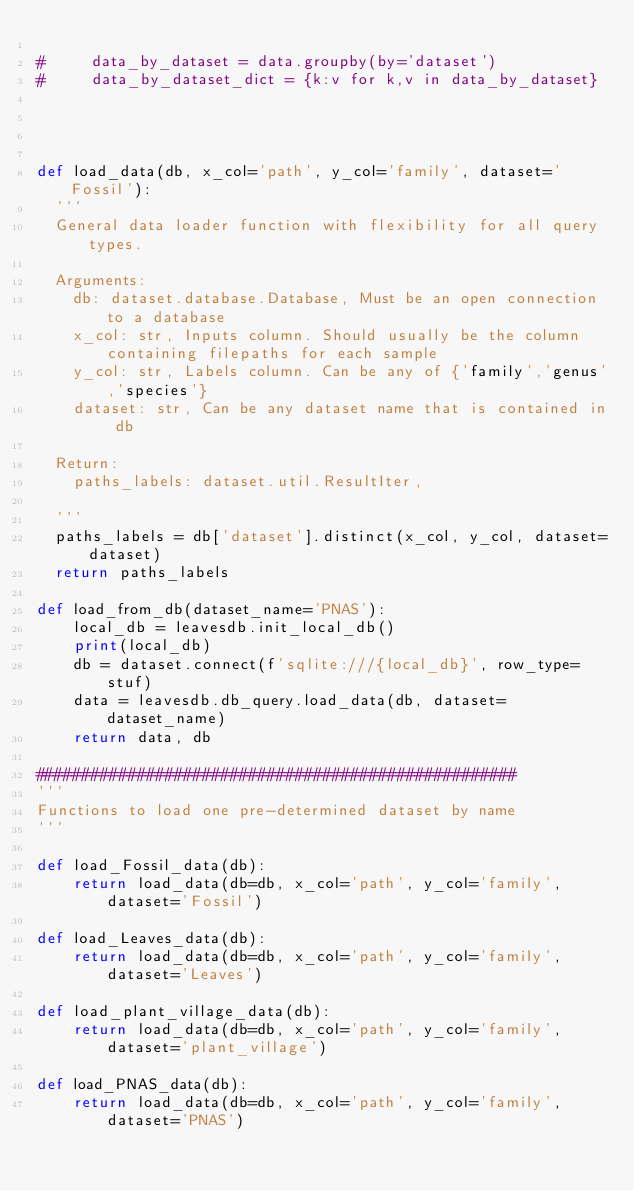<code> <loc_0><loc_0><loc_500><loc_500><_Python_>
#     data_by_dataset = data.groupby(by='dataset')
#     data_by_dataset_dict = {k:v for k,v in data_by_dataset}
    

    

def load_data(db, x_col='path', y_col='family', dataset='Fossil'):
	'''
	General data loader function with flexibility for all query types.

	Arguments:
		db: dataset.database.Database, Must be an open connection to a database
		x_col: str, Inputs column. Should usually be the column containing filepaths for each sample
		y_col: str, Labels column. Can be any of {'family','genus','species'}
		dataset: str, Can be any dataset name that is contained in db

	Return:
		paths_labels: dataset.util.ResultIter,

	'''
	paths_labels = db['dataset'].distinct(x_col, y_col, dataset=dataset)
	return paths_labels

def load_from_db(dataset_name='PNAS'):
    local_db = leavesdb.init_local_db()
    print(local_db)
    db = dataset.connect(f'sqlite:///{local_db}', row_type=stuf)
    data = leavesdb.db_query.load_data(db, dataset=dataset_name)
    return data, db

####################################################
'''
Functions to load one pre-determined dataset by name
'''

def load_Fossil_data(db):
    return load_data(db=db, x_col='path', y_col='family', dataset='Fossil')

def load_Leaves_data(db):
    return load_data(db=db, x_col='path', y_col='family', dataset='Leaves')

def load_plant_village_data(db):
    return load_data(db=db, x_col='path', y_col='family', dataset='plant_village')

def load_PNAS_data(db):
    return load_data(db=db, x_col='path', y_col='family', dataset='PNAS')
</code> 